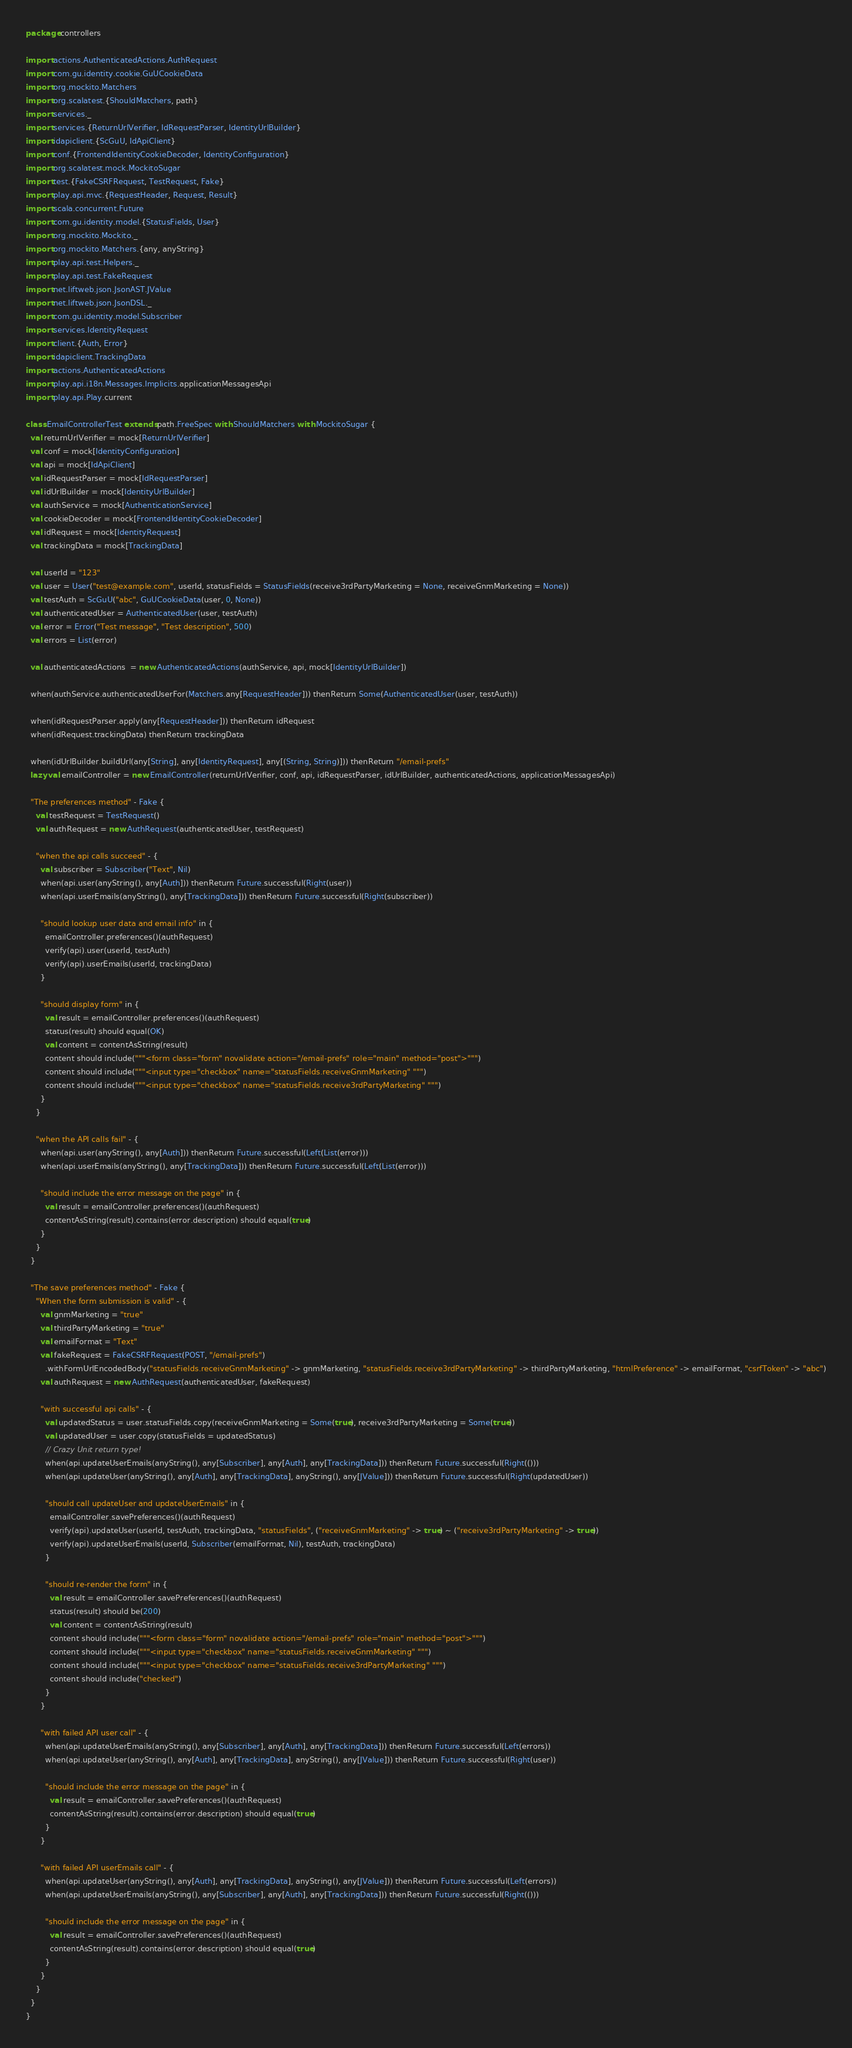Convert code to text. <code><loc_0><loc_0><loc_500><loc_500><_Scala_>package controllers

import actions.AuthenticatedActions.AuthRequest
import com.gu.identity.cookie.GuUCookieData
import org.mockito.Matchers
import org.scalatest.{ShouldMatchers, path}
import services._
import services.{ReturnUrlVerifier, IdRequestParser, IdentityUrlBuilder}
import idapiclient.{ScGuU, IdApiClient}
import conf.{FrontendIdentityCookieDecoder, IdentityConfiguration}
import org.scalatest.mock.MockitoSugar
import test.{FakeCSRFRequest, TestRequest, Fake}
import play.api.mvc.{RequestHeader, Request, Result}
import scala.concurrent.Future
import com.gu.identity.model.{StatusFields, User}
import org.mockito.Mockito._
import org.mockito.Matchers.{any, anyString}
import play.api.test.Helpers._
import play.api.test.FakeRequest
import net.liftweb.json.JsonAST.JValue
import net.liftweb.json.JsonDSL._
import com.gu.identity.model.Subscriber
import services.IdentityRequest
import client.{Auth, Error}
import idapiclient.TrackingData
import actions.AuthenticatedActions
import play.api.i18n.Messages.Implicits.applicationMessagesApi
import play.api.Play.current

class EmailControllerTest extends path.FreeSpec with ShouldMatchers with MockitoSugar {
  val returnUrlVerifier = mock[ReturnUrlVerifier]
  val conf = mock[IdentityConfiguration]
  val api = mock[IdApiClient]
  val idRequestParser = mock[IdRequestParser]
  val idUrlBuilder = mock[IdentityUrlBuilder]
  val authService = mock[AuthenticationService]
  val cookieDecoder = mock[FrontendIdentityCookieDecoder]
  val idRequest = mock[IdentityRequest]
  val trackingData = mock[TrackingData]

  val userId = "123"
  val user = User("test@example.com", userId, statusFields = StatusFields(receive3rdPartyMarketing = None, receiveGnmMarketing = None))
  val testAuth = ScGuU("abc", GuUCookieData(user, 0, None))
  val authenticatedUser = AuthenticatedUser(user, testAuth)
  val error = Error("Test message", "Test description", 500)
  val errors = List(error)

  val authenticatedActions  = new AuthenticatedActions(authService, api, mock[IdentityUrlBuilder])

  when(authService.authenticatedUserFor(Matchers.any[RequestHeader])) thenReturn Some(AuthenticatedUser(user, testAuth))

  when(idRequestParser.apply(any[RequestHeader])) thenReturn idRequest
  when(idRequest.trackingData) thenReturn trackingData

  when(idUrlBuilder.buildUrl(any[String], any[IdentityRequest], any[(String, String)])) thenReturn "/email-prefs"
  lazy val emailController = new EmailController(returnUrlVerifier, conf, api, idRequestParser, idUrlBuilder, authenticatedActions, applicationMessagesApi)

  "The preferences method" - Fake {
    val testRequest = TestRequest()
    val authRequest = new AuthRequest(authenticatedUser, testRequest)

    "when the api calls succeed" - {
      val subscriber = Subscriber("Text", Nil)
      when(api.user(anyString(), any[Auth])) thenReturn Future.successful(Right(user))
      when(api.userEmails(anyString(), any[TrackingData])) thenReturn Future.successful(Right(subscriber))

      "should lookup user data and email info" in {
        emailController.preferences()(authRequest)
        verify(api).user(userId, testAuth)
        verify(api).userEmails(userId, trackingData)
      }

      "should display form" in {
        val result = emailController.preferences()(authRequest)
        status(result) should equal(OK)
        val content = contentAsString(result)
        content should include("""<form class="form" novalidate action="/email-prefs" role="main" method="post">""")
        content should include("""<input type="checkbox" name="statusFields.receiveGnmMarketing" """)
        content should include("""<input type="checkbox" name="statusFields.receive3rdPartyMarketing" """)
      }
    }

    "when the API calls fail" - {
      when(api.user(anyString(), any[Auth])) thenReturn Future.successful(Left(List(error)))
      when(api.userEmails(anyString(), any[TrackingData])) thenReturn Future.successful(Left(List(error)))

      "should include the error message on the page" in {
        val result = emailController.preferences()(authRequest)
        contentAsString(result).contains(error.description) should equal(true)
      }
    }
  }

  "The save preferences method" - Fake {
    "When the form submission is valid" - {
      val gnmMarketing = "true"
      val thirdPartyMarketing = "true"
      val emailFormat = "Text"
      val fakeRequest = FakeCSRFRequest(POST, "/email-prefs")
        .withFormUrlEncodedBody("statusFields.receiveGnmMarketing" -> gnmMarketing, "statusFields.receive3rdPartyMarketing" -> thirdPartyMarketing, "htmlPreference" -> emailFormat, "csrfToken" -> "abc")
      val authRequest = new AuthRequest(authenticatedUser, fakeRequest)

      "with successful api calls" - {
        val updatedStatus = user.statusFields.copy(receiveGnmMarketing = Some(true), receive3rdPartyMarketing = Some(true))
        val updatedUser = user.copy(statusFields = updatedStatus)
        // Crazy Unit return type!
        when(api.updateUserEmails(anyString(), any[Subscriber], any[Auth], any[TrackingData])) thenReturn Future.successful(Right(()))
        when(api.updateUser(anyString(), any[Auth], any[TrackingData], anyString(), any[JValue])) thenReturn Future.successful(Right(updatedUser))

        "should call updateUser and updateUserEmails" in {
          emailController.savePreferences()(authRequest)
          verify(api).updateUser(userId, testAuth, trackingData, "statusFields", ("receiveGnmMarketing" -> true) ~ ("receive3rdPartyMarketing" -> true))
          verify(api).updateUserEmails(userId, Subscriber(emailFormat, Nil), testAuth, trackingData)
        }

        "should re-render the form" in {
          val result = emailController.savePreferences()(authRequest)
          status(result) should be(200)
          val content = contentAsString(result)
          content should include("""<form class="form" novalidate action="/email-prefs" role="main" method="post">""")
          content should include("""<input type="checkbox" name="statusFields.receiveGnmMarketing" """)
          content should include("""<input type="checkbox" name="statusFields.receive3rdPartyMarketing" """)
          content should include("checked")
        }
      }

      "with failed API user call" - {
        when(api.updateUserEmails(anyString(), any[Subscriber], any[Auth], any[TrackingData])) thenReturn Future.successful(Left(errors))
        when(api.updateUser(anyString(), any[Auth], any[TrackingData], anyString(), any[JValue])) thenReturn Future.successful(Right(user))

        "should include the error message on the page" in {
          val result = emailController.savePreferences()(authRequest)
          contentAsString(result).contains(error.description) should equal(true)
        }
      }

      "with failed API userEmails call" - {
        when(api.updateUser(anyString(), any[Auth], any[TrackingData], anyString(), any[JValue])) thenReturn Future.successful(Left(errors))
        when(api.updateUserEmails(anyString(), any[Subscriber], any[Auth], any[TrackingData])) thenReturn Future.successful(Right(()))

        "should include the error message on the page" in {
          val result = emailController.savePreferences()(authRequest)
          contentAsString(result).contains(error.description) should equal(true)
        }
      }
    }
  }
}
</code> 